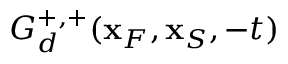<formula> <loc_0><loc_0><loc_500><loc_500>G _ { d } ^ { + , + } ( { x } _ { F } , { x } _ { S } , - t )</formula> 